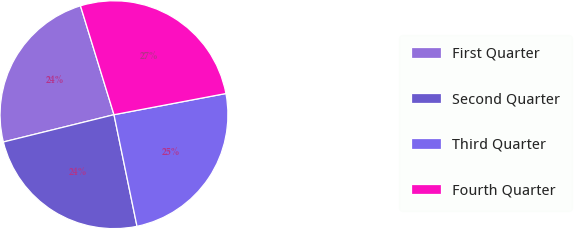Convert chart to OTSL. <chart><loc_0><loc_0><loc_500><loc_500><pie_chart><fcel>First Quarter<fcel>Second Quarter<fcel>Third Quarter<fcel>Fourth Quarter<nl><fcel>24.1%<fcel>24.39%<fcel>24.74%<fcel>26.78%<nl></chart> 